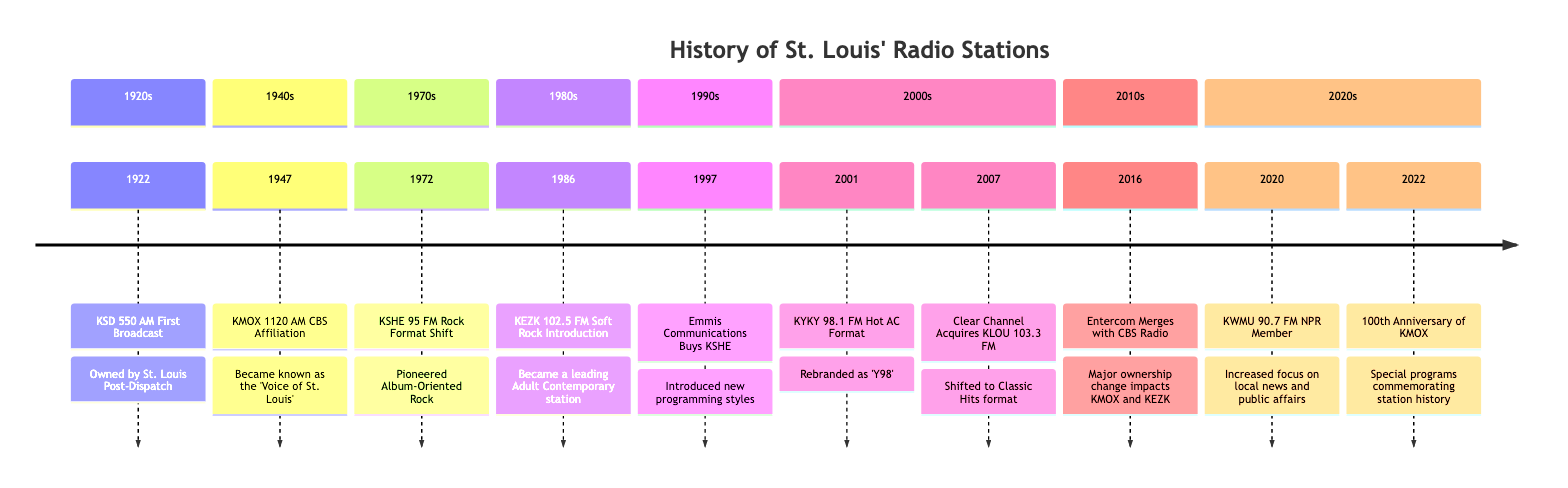What year did KSD first broadcast? KSD 550 AM was first broadcast in 1922, as indicated in the diagram under the 1920s section.
Answer: 1922 Who owned KMOX when it became known as the 'Voice of St. Louis'? The diagram specifies that KMOX 1120 AM had a CBS affiliation in 1947, indicating that it was owned by CBS at that time.
Answer: CBS What significant format shift occurred at KSHE in the 1970s? According to the 1970s section, KSHE 95 FM shifted to a Rock format, specifically pioneering Album-Oriented Rock, which is a notable change in its programming approach.
Answer: Rock format How many major ownership changes are listed from the timeline? The timeline includes two major ownership changes: the merger of Entercom with CBS Radio in 2016 and the acquisition of KSHE by Emmis Communications in 1997, totaling two significant ownership changes.
Answer: 2 Which radio station celebrated its 100th anniversary in 2022? The 2022 entry in the timeline clearly states that KMOX celebrated its 100th anniversary, evidenced by the special programs dedicated to commemorating the station's history.
Answer: KMOX What event in the 2000s was related to Clear Channel? The acquisition of KLOU 103.3 FM by Clear Channel in 2007 is identified in the timeline, which notes a shift to a Classic Hits format, showcasing a key operational change during that decade.
Answer: KLOU 103.3 FM What type of programming did KWMU increase its focus on in 2020? From the information in the 2020 section of the timeline, it mentions that KWMU 90.7 FM increased its focus on local news and public affairs, indicating a shift in its programming strategy aimed at community engagement.
Answer: Local news and public affairs What was the significance of the year 1986 in St. Louis radio history? The year 1986 is marked in the diagram as when KEZK 102.5 FM introduced the Soft Rock format, which led to it becoming a leading Adult Contemporary station, reflecting an evolution in music programming in St. Louis.
Answer: Soft Rock Introduction 